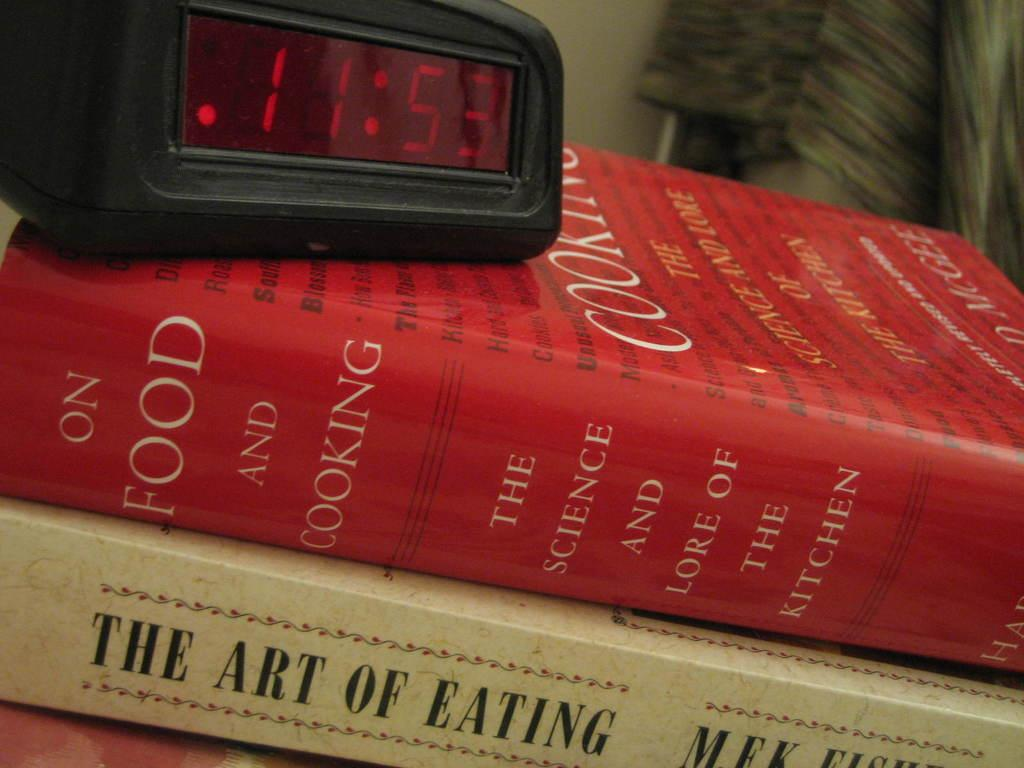<image>
Summarize the visual content of the image. the word eating is on the white book under the red one 